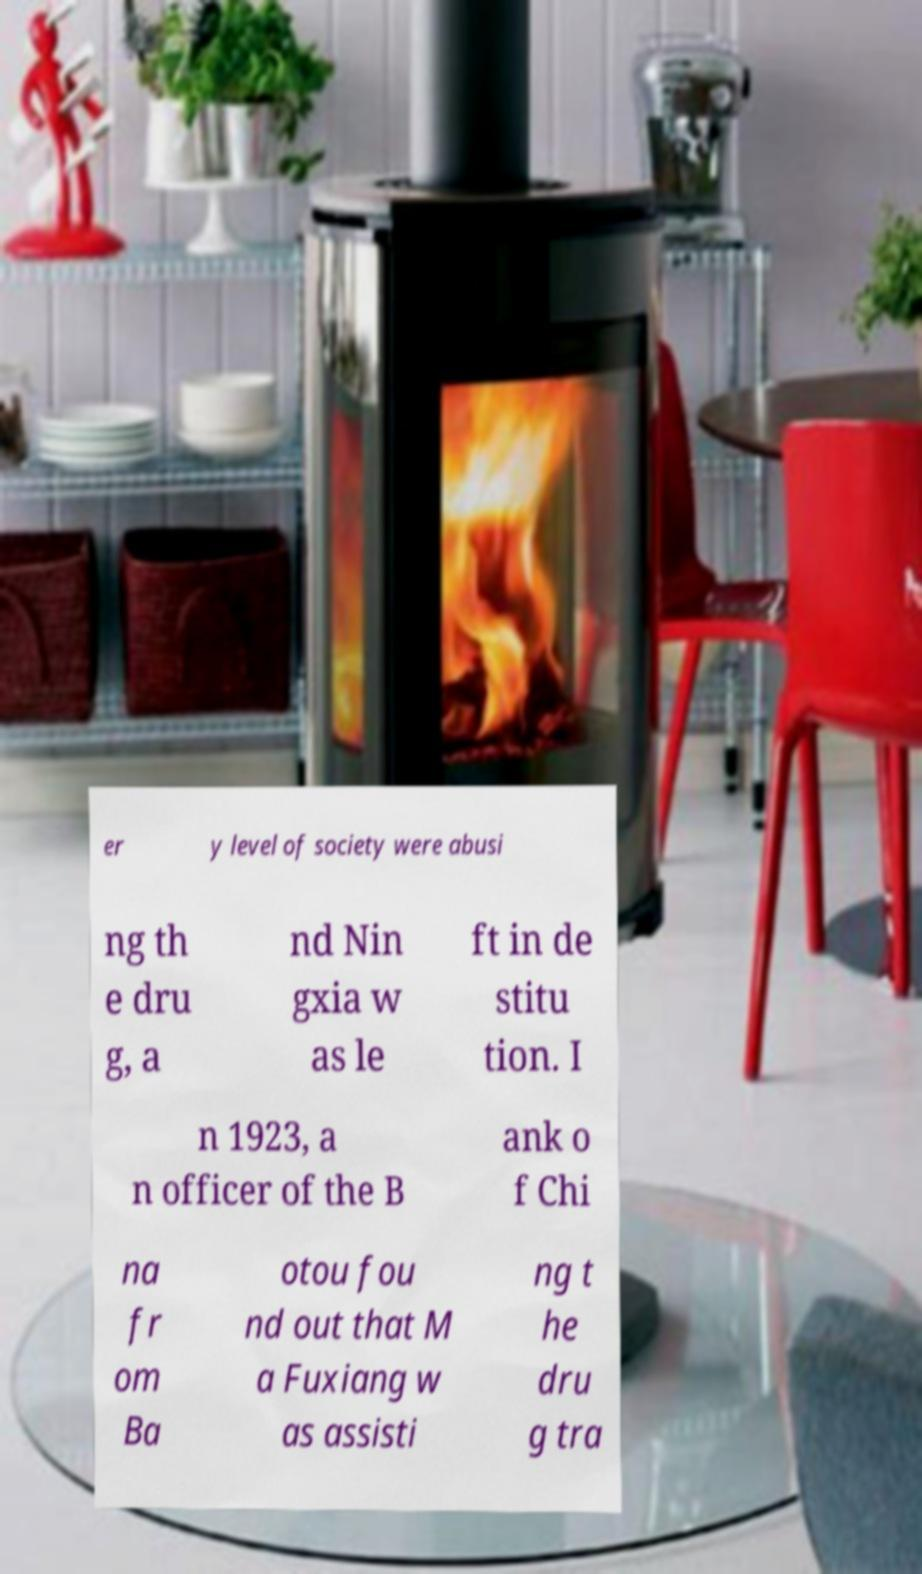Please identify and transcribe the text found in this image. er y level of society were abusi ng th e dru g, a nd Nin gxia w as le ft in de stitu tion. I n 1923, a n officer of the B ank o f Chi na fr om Ba otou fou nd out that M a Fuxiang w as assisti ng t he dru g tra 